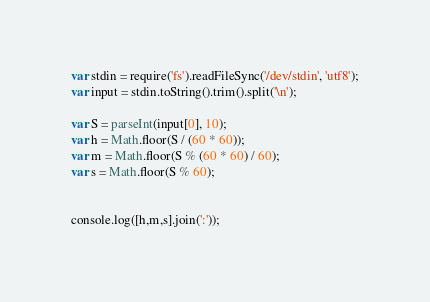<code> <loc_0><loc_0><loc_500><loc_500><_JavaScript_>var stdin = require('fs').readFileSync('/dev/stdin', 'utf8');
var input = stdin.toString().trim().split('\n');

var S = parseInt(input[0], 10);
var h = Math.floor(S / (60 * 60));
var m = Math.floor(S % (60 * 60) / 60);
var s = Math.floor(S % 60);


console.log([h,m,s].join(':'));</code> 